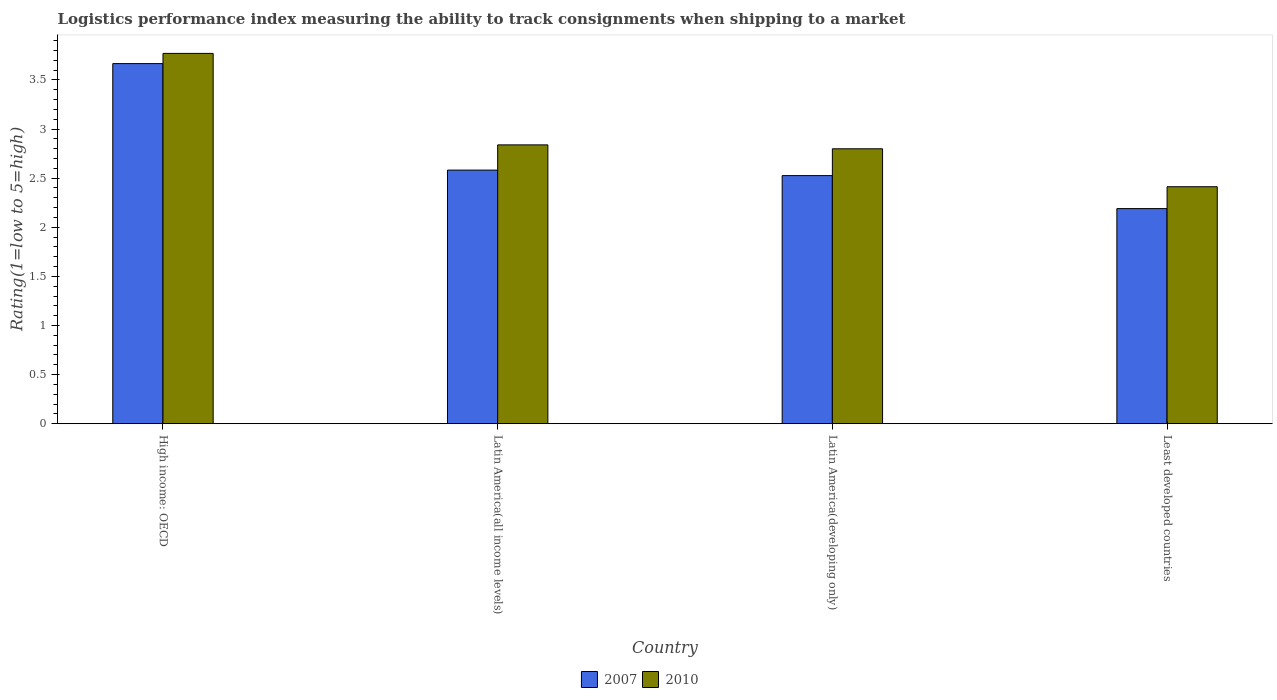How many groups of bars are there?
Provide a short and direct response. 4. How many bars are there on the 4th tick from the left?
Your answer should be compact. 2. How many bars are there on the 1st tick from the right?
Give a very brief answer. 2. What is the label of the 4th group of bars from the left?
Give a very brief answer. Least developed countries. What is the Logistic performance index in 2007 in Latin America(all income levels)?
Your answer should be compact. 2.58. Across all countries, what is the maximum Logistic performance index in 2007?
Keep it short and to the point. 3.67. Across all countries, what is the minimum Logistic performance index in 2007?
Your answer should be very brief. 2.19. In which country was the Logistic performance index in 2007 maximum?
Your answer should be compact. High income: OECD. In which country was the Logistic performance index in 2010 minimum?
Provide a succinct answer. Least developed countries. What is the total Logistic performance index in 2010 in the graph?
Ensure brevity in your answer.  11.82. What is the difference between the Logistic performance index in 2010 in High income: OECD and that in Latin America(developing only)?
Offer a very short reply. 0.97. What is the difference between the Logistic performance index in 2007 in Latin America(all income levels) and the Logistic performance index in 2010 in High income: OECD?
Your answer should be compact. -1.19. What is the average Logistic performance index in 2007 per country?
Provide a succinct answer. 2.74. What is the difference between the Logistic performance index of/in 2010 and Logistic performance index of/in 2007 in Latin America(developing only)?
Your answer should be compact. 0.27. In how many countries, is the Logistic performance index in 2010 greater than 3.3?
Offer a very short reply. 1. What is the ratio of the Logistic performance index in 2007 in High income: OECD to that in Least developed countries?
Make the answer very short. 1.67. What is the difference between the highest and the second highest Logistic performance index in 2007?
Offer a very short reply. -1.08. What is the difference between the highest and the lowest Logistic performance index in 2010?
Ensure brevity in your answer.  1.36. In how many countries, is the Logistic performance index in 2010 greater than the average Logistic performance index in 2010 taken over all countries?
Offer a terse response. 1. Is the sum of the Logistic performance index in 2010 in Latin America(all income levels) and Latin America(developing only) greater than the maximum Logistic performance index in 2007 across all countries?
Offer a terse response. Yes. How many bars are there?
Offer a very short reply. 8. How many countries are there in the graph?
Offer a very short reply. 4. Are the values on the major ticks of Y-axis written in scientific E-notation?
Give a very brief answer. No. Does the graph contain any zero values?
Offer a terse response. No. Where does the legend appear in the graph?
Make the answer very short. Bottom center. What is the title of the graph?
Make the answer very short. Logistics performance index measuring the ability to track consignments when shipping to a market. Does "1968" appear as one of the legend labels in the graph?
Your answer should be compact. No. What is the label or title of the X-axis?
Make the answer very short. Country. What is the label or title of the Y-axis?
Provide a short and direct response. Rating(1=low to 5=high). What is the Rating(1=low to 5=high) in 2007 in High income: OECD?
Your answer should be very brief. 3.67. What is the Rating(1=low to 5=high) of 2010 in High income: OECD?
Your answer should be compact. 3.77. What is the Rating(1=low to 5=high) of 2007 in Latin America(all income levels)?
Give a very brief answer. 2.58. What is the Rating(1=low to 5=high) of 2010 in Latin America(all income levels)?
Provide a succinct answer. 2.84. What is the Rating(1=low to 5=high) of 2007 in Latin America(developing only)?
Offer a very short reply. 2.53. What is the Rating(1=low to 5=high) of 2010 in Latin America(developing only)?
Offer a very short reply. 2.8. What is the Rating(1=low to 5=high) in 2007 in Least developed countries?
Offer a very short reply. 2.19. What is the Rating(1=low to 5=high) in 2010 in Least developed countries?
Offer a terse response. 2.41. Across all countries, what is the maximum Rating(1=low to 5=high) in 2007?
Your answer should be compact. 3.67. Across all countries, what is the maximum Rating(1=low to 5=high) of 2010?
Your answer should be compact. 3.77. Across all countries, what is the minimum Rating(1=low to 5=high) of 2007?
Provide a short and direct response. 2.19. Across all countries, what is the minimum Rating(1=low to 5=high) of 2010?
Offer a very short reply. 2.41. What is the total Rating(1=low to 5=high) in 2007 in the graph?
Your answer should be compact. 10.96. What is the total Rating(1=low to 5=high) in 2010 in the graph?
Give a very brief answer. 11.82. What is the difference between the Rating(1=low to 5=high) in 2007 in High income: OECD and that in Latin America(all income levels)?
Your answer should be very brief. 1.08. What is the difference between the Rating(1=low to 5=high) of 2010 in High income: OECD and that in Latin America(all income levels)?
Offer a very short reply. 0.93. What is the difference between the Rating(1=low to 5=high) in 2007 in High income: OECD and that in Latin America(developing only)?
Your answer should be very brief. 1.14. What is the difference between the Rating(1=low to 5=high) of 2010 in High income: OECD and that in Latin America(developing only)?
Provide a short and direct response. 0.97. What is the difference between the Rating(1=low to 5=high) in 2007 in High income: OECD and that in Least developed countries?
Give a very brief answer. 1.48. What is the difference between the Rating(1=low to 5=high) of 2010 in High income: OECD and that in Least developed countries?
Your answer should be compact. 1.36. What is the difference between the Rating(1=low to 5=high) of 2007 in Latin America(all income levels) and that in Latin America(developing only)?
Provide a succinct answer. 0.06. What is the difference between the Rating(1=low to 5=high) of 2010 in Latin America(all income levels) and that in Latin America(developing only)?
Your response must be concise. 0.04. What is the difference between the Rating(1=low to 5=high) in 2007 in Latin America(all income levels) and that in Least developed countries?
Make the answer very short. 0.39. What is the difference between the Rating(1=low to 5=high) of 2010 in Latin America(all income levels) and that in Least developed countries?
Provide a succinct answer. 0.43. What is the difference between the Rating(1=low to 5=high) in 2007 in Latin America(developing only) and that in Least developed countries?
Offer a very short reply. 0.34. What is the difference between the Rating(1=low to 5=high) of 2010 in Latin America(developing only) and that in Least developed countries?
Keep it short and to the point. 0.39. What is the difference between the Rating(1=low to 5=high) of 2007 in High income: OECD and the Rating(1=low to 5=high) of 2010 in Latin America(all income levels)?
Give a very brief answer. 0.83. What is the difference between the Rating(1=low to 5=high) of 2007 in High income: OECD and the Rating(1=low to 5=high) of 2010 in Latin America(developing only)?
Provide a succinct answer. 0.87. What is the difference between the Rating(1=low to 5=high) of 2007 in High income: OECD and the Rating(1=low to 5=high) of 2010 in Least developed countries?
Your response must be concise. 1.25. What is the difference between the Rating(1=low to 5=high) of 2007 in Latin America(all income levels) and the Rating(1=low to 5=high) of 2010 in Latin America(developing only)?
Your answer should be very brief. -0.22. What is the difference between the Rating(1=low to 5=high) in 2007 in Latin America(all income levels) and the Rating(1=low to 5=high) in 2010 in Least developed countries?
Make the answer very short. 0.17. What is the difference between the Rating(1=low to 5=high) of 2007 in Latin America(developing only) and the Rating(1=low to 5=high) of 2010 in Least developed countries?
Your response must be concise. 0.11. What is the average Rating(1=low to 5=high) of 2007 per country?
Your response must be concise. 2.74. What is the average Rating(1=low to 5=high) in 2010 per country?
Give a very brief answer. 2.96. What is the difference between the Rating(1=low to 5=high) of 2007 and Rating(1=low to 5=high) of 2010 in High income: OECD?
Your response must be concise. -0.1. What is the difference between the Rating(1=low to 5=high) in 2007 and Rating(1=low to 5=high) in 2010 in Latin America(all income levels)?
Make the answer very short. -0.26. What is the difference between the Rating(1=low to 5=high) in 2007 and Rating(1=low to 5=high) in 2010 in Latin America(developing only)?
Your response must be concise. -0.27. What is the difference between the Rating(1=low to 5=high) in 2007 and Rating(1=low to 5=high) in 2010 in Least developed countries?
Keep it short and to the point. -0.22. What is the ratio of the Rating(1=low to 5=high) in 2007 in High income: OECD to that in Latin America(all income levels)?
Keep it short and to the point. 1.42. What is the ratio of the Rating(1=low to 5=high) in 2010 in High income: OECD to that in Latin America(all income levels)?
Your answer should be compact. 1.33. What is the ratio of the Rating(1=low to 5=high) of 2007 in High income: OECD to that in Latin America(developing only)?
Provide a short and direct response. 1.45. What is the ratio of the Rating(1=low to 5=high) of 2010 in High income: OECD to that in Latin America(developing only)?
Provide a succinct answer. 1.35. What is the ratio of the Rating(1=low to 5=high) in 2007 in High income: OECD to that in Least developed countries?
Provide a succinct answer. 1.67. What is the ratio of the Rating(1=low to 5=high) of 2010 in High income: OECD to that in Least developed countries?
Provide a succinct answer. 1.56. What is the ratio of the Rating(1=low to 5=high) of 2007 in Latin America(all income levels) to that in Latin America(developing only)?
Offer a terse response. 1.02. What is the ratio of the Rating(1=low to 5=high) of 2010 in Latin America(all income levels) to that in Latin America(developing only)?
Offer a very short reply. 1.01. What is the ratio of the Rating(1=low to 5=high) of 2007 in Latin America(all income levels) to that in Least developed countries?
Your answer should be compact. 1.18. What is the ratio of the Rating(1=low to 5=high) of 2010 in Latin America(all income levels) to that in Least developed countries?
Your answer should be compact. 1.18. What is the ratio of the Rating(1=low to 5=high) in 2007 in Latin America(developing only) to that in Least developed countries?
Offer a very short reply. 1.15. What is the ratio of the Rating(1=low to 5=high) in 2010 in Latin America(developing only) to that in Least developed countries?
Offer a very short reply. 1.16. What is the difference between the highest and the second highest Rating(1=low to 5=high) of 2007?
Give a very brief answer. 1.08. What is the difference between the highest and the second highest Rating(1=low to 5=high) in 2010?
Give a very brief answer. 0.93. What is the difference between the highest and the lowest Rating(1=low to 5=high) in 2007?
Your answer should be compact. 1.48. What is the difference between the highest and the lowest Rating(1=low to 5=high) in 2010?
Offer a very short reply. 1.36. 